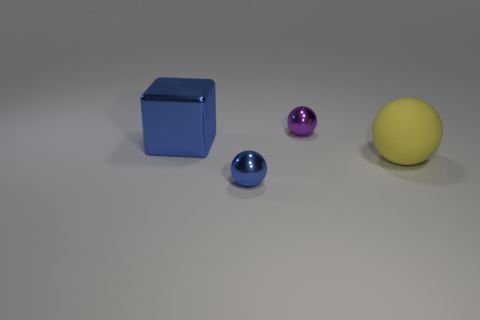Add 1 small shiny objects. How many objects exist? 5 Subtract all cubes. How many objects are left? 3 Add 1 large yellow objects. How many large yellow objects exist? 2 Subtract 0 green cylinders. How many objects are left? 4 Subtract all spheres. Subtract all cyan metal cylinders. How many objects are left? 1 Add 2 big yellow things. How many big yellow things are left? 3 